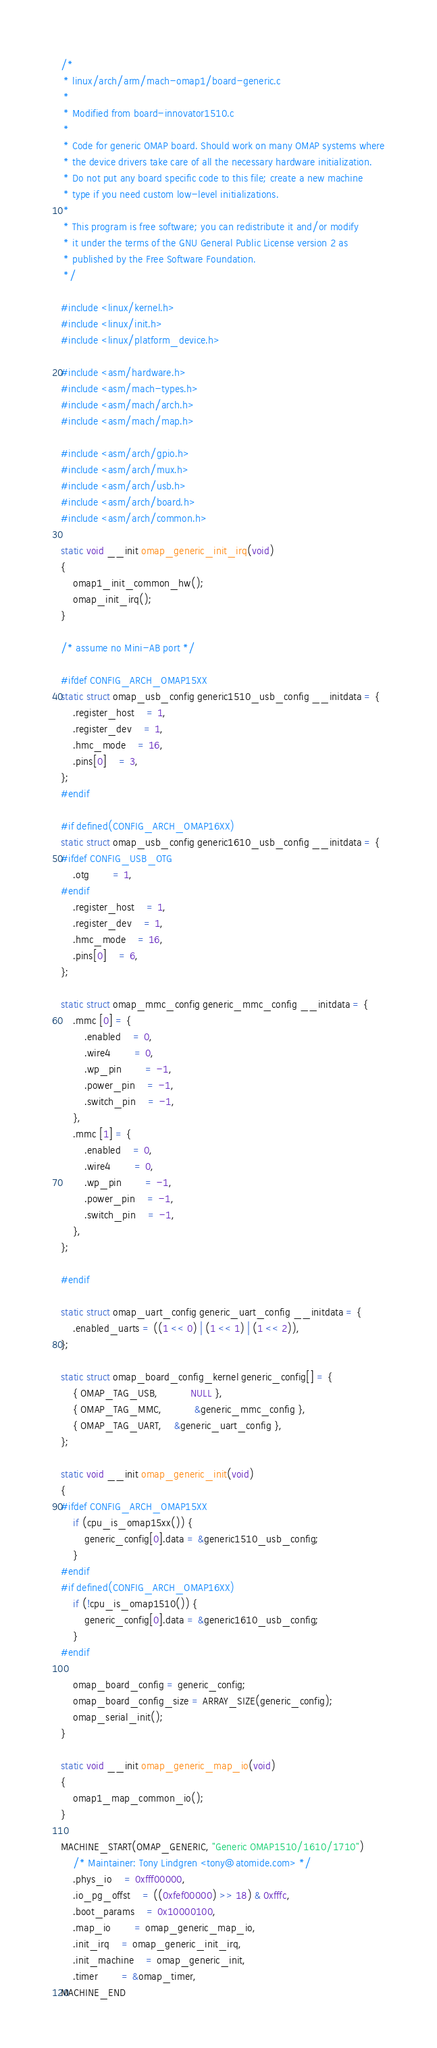Convert code to text. <code><loc_0><loc_0><loc_500><loc_500><_C_>/*
 * linux/arch/arm/mach-omap1/board-generic.c
 *
 * Modified from board-innovator1510.c
 *
 * Code for generic OMAP board. Should work on many OMAP systems where
 * the device drivers take care of all the necessary hardware initialization.
 * Do not put any board specific code to this file; create a new machine
 * type if you need custom low-level initializations.
 *
 * This program is free software; you can redistribute it and/or modify
 * it under the terms of the GNU General Public License version 2 as
 * published by the Free Software Foundation.
 */

#include <linux/kernel.h>
#include <linux/init.h>
#include <linux/platform_device.h>

#include <asm/hardware.h>
#include <asm/mach-types.h>
#include <asm/mach/arch.h>
#include <asm/mach/map.h>

#include <asm/arch/gpio.h>
#include <asm/arch/mux.h>
#include <asm/arch/usb.h>
#include <asm/arch/board.h>
#include <asm/arch/common.h>

static void __init omap_generic_init_irq(void)
{
	omap1_init_common_hw();
	omap_init_irq();
}

/* assume no Mini-AB port */

#ifdef CONFIG_ARCH_OMAP15XX
static struct omap_usb_config generic1510_usb_config __initdata = {
	.register_host	= 1,
	.register_dev	= 1,
	.hmc_mode	= 16,
	.pins[0]	= 3,
};
#endif

#if defined(CONFIG_ARCH_OMAP16XX)
static struct omap_usb_config generic1610_usb_config __initdata = {
#ifdef CONFIG_USB_OTG
	.otg		= 1,
#endif
	.register_host	= 1,
	.register_dev	= 1,
	.hmc_mode	= 16,
	.pins[0]	= 6,
};

static struct omap_mmc_config generic_mmc_config __initdata = {
	.mmc [0] = {
		.enabled 	= 0,
		.wire4		= 0,
		.wp_pin		= -1,
		.power_pin	= -1,
		.switch_pin	= -1,
	},
	.mmc [1] = {
		.enabled 	= 0,
		.wire4		= 0,
		.wp_pin		= -1,
		.power_pin	= -1,
		.switch_pin	= -1,
	},
};

#endif

static struct omap_uart_config generic_uart_config __initdata = {
	.enabled_uarts = ((1 << 0) | (1 << 1) | (1 << 2)),
};

static struct omap_board_config_kernel generic_config[] = {
	{ OMAP_TAG_USB,           NULL },
	{ OMAP_TAG_MMC,           &generic_mmc_config },
	{ OMAP_TAG_UART,	&generic_uart_config },
};

static void __init omap_generic_init(void)
{
#ifdef CONFIG_ARCH_OMAP15XX
	if (cpu_is_omap15xx()) {
		generic_config[0].data = &generic1510_usb_config;
	}
#endif
#if defined(CONFIG_ARCH_OMAP16XX)
	if (!cpu_is_omap1510()) {
		generic_config[0].data = &generic1610_usb_config;
	}
#endif

	omap_board_config = generic_config;
	omap_board_config_size = ARRAY_SIZE(generic_config);
	omap_serial_init();
}

static void __init omap_generic_map_io(void)
{
	omap1_map_common_io();
}

MACHINE_START(OMAP_GENERIC, "Generic OMAP1510/1610/1710")
	/* Maintainer: Tony Lindgren <tony@atomide.com> */
	.phys_io	= 0xfff00000,
	.io_pg_offst	= ((0xfef00000) >> 18) & 0xfffc,
	.boot_params	= 0x10000100,
	.map_io		= omap_generic_map_io,
	.init_irq	= omap_generic_init_irq,
	.init_machine	= omap_generic_init,
	.timer		= &omap_timer,
MACHINE_END
</code> 